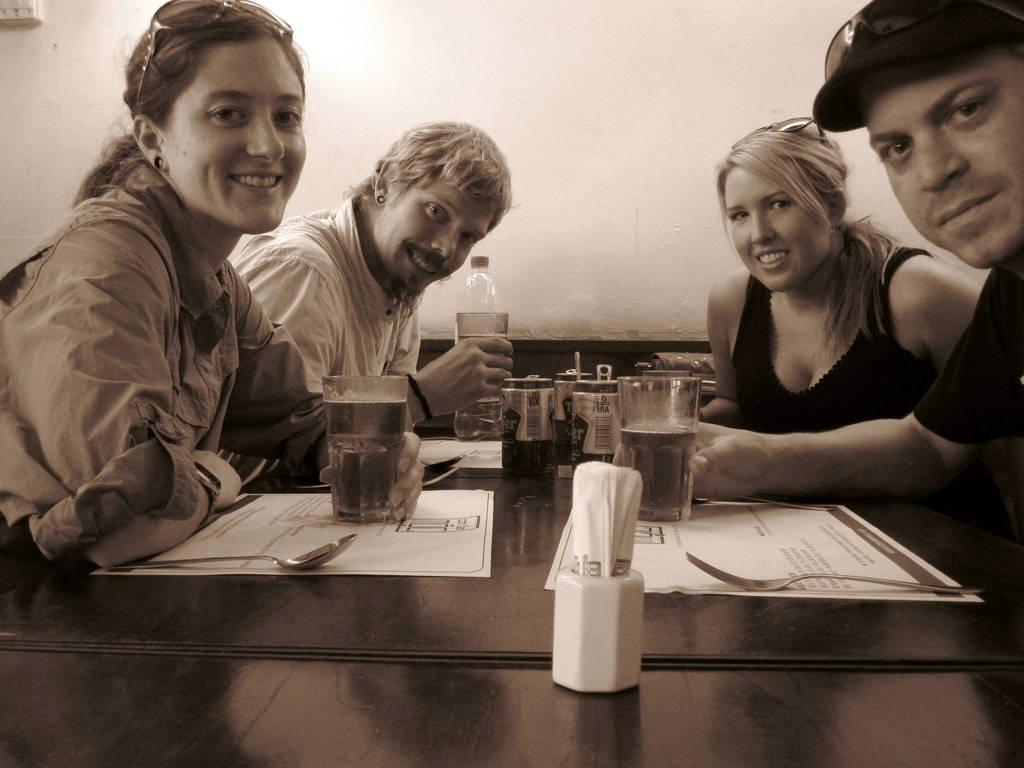How many people are sitting in the image? There are 4 people sitting in the image. What are the people at the front holding? The people at the front are holding a glass. What is the person at the back holding? The person at the back is holding a bottle. What utensils can be seen on the table? There are spoons on the table. What type of paper products are present on the table? There are tissue papers on the table. Is there any mist visible in the image? No, there is no mist present in the image. 